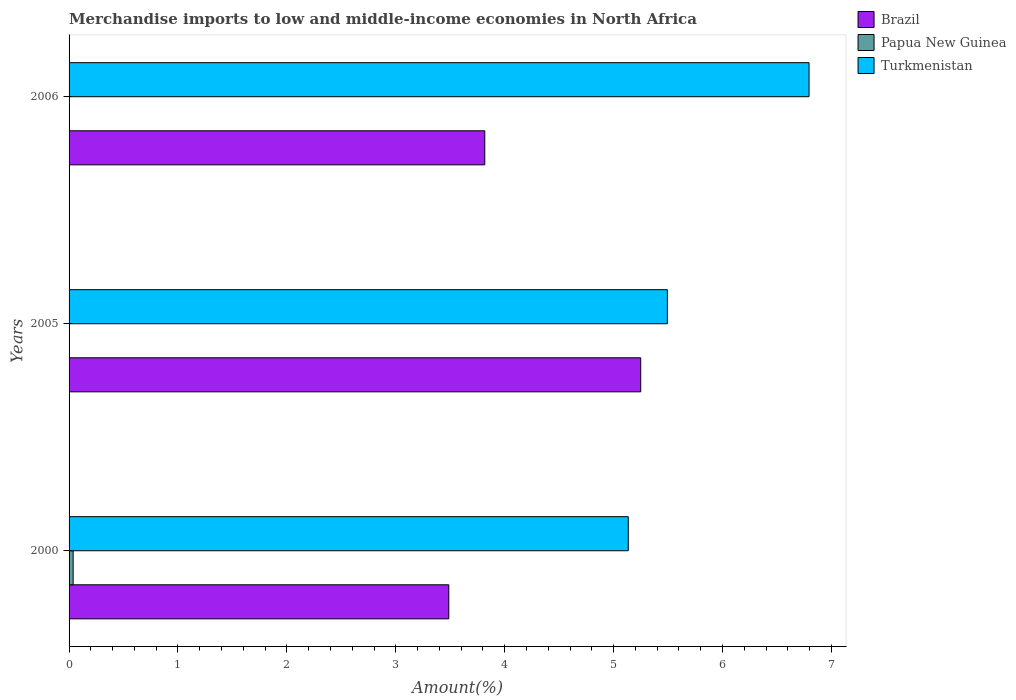How many different coloured bars are there?
Provide a succinct answer. 3. How many bars are there on the 2nd tick from the bottom?
Your answer should be very brief. 3. What is the percentage of amount earned from merchandise imports in Brazil in 2006?
Give a very brief answer. 3.82. Across all years, what is the maximum percentage of amount earned from merchandise imports in Brazil?
Provide a succinct answer. 5.25. Across all years, what is the minimum percentage of amount earned from merchandise imports in Brazil?
Keep it short and to the point. 3.49. In which year was the percentage of amount earned from merchandise imports in Brazil minimum?
Offer a very short reply. 2000. What is the total percentage of amount earned from merchandise imports in Brazil in the graph?
Keep it short and to the point. 12.55. What is the difference between the percentage of amount earned from merchandise imports in Papua New Guinea in 2000 and that in 2006?
Your response must be concise. 0.04. What is the difference between the percentage of amount earned from merchandise imports in Turkmenistan in 2006 and the percentage of amount earned from merchandise imports in Brazil in 2000?
Your answer should be compact. 3.31. What is the average percentage of amount earned from merchandise imports in Turkmenistan per year?
Your answer should be compact. 5.81. In the year 2000, what is the difference between the percentage of amount earned from merchandise imports in Brazil and percentage of amount earned from merchandise imports in Turkmenistan?
Make the answer very short. -1.65. What is the ratio of the percentage of amount earned from merchandise imports in Papua New Guinea in 2000 to that in 2005?
Give a very brief answer. 518.41. What is the difference between the highest and the second highest percentage of amount earned from merchandise imports in Turkmenistan?
Your answer should be very brief. 1.3. What is the difference between the highest and the lowest percentage of amount earned from merchandise imports in Papua New Guinea?
Make the answer very short. 0.04. What does the 3rd bar from the top in 2000 represents?
Your response must be concise. Brazil. What does the 2nd bar from the bottom in 2005 represents?
Keep it short and to the point. Papua New Guinea. Is it the case that in every year, the sum of the percentage of amount earned from merchandise imports in Papua New Guinea and percentage of amount earned from merchandise imports in Brazil is greater than the percentage of amount earned from merchandise imports in Turkmenistan?
Ensure brevity in your answer.  No. What is the difference between two consecutive major ticks on the X-axis?
Ensure brevity in your answer.  1. Does the graph contain any zero values?
Your answer should be very brief. No. Does the graph contain grids?
Your answer should be compact. No. How many legend labels are there?
Offer a terse response. 3. How are the legend labels stacked?
Offer a terse response. Vertical. What is the title of the graph?
Keep it short and to the point. Merchandise imports to low and middle-income economies in North Africa. Does "India" appear as one of the legend labels in the graph?
Your response must be concise. No. What is the label or title of the X-axis?
Offer a very short reply. Amount(%). What is the Amount(%) in Brazil in 2000?
Your answer should be very brief. 3.49. What is the Amount(%) in Papua New Guinea in 2000?
Offer a terse response. 0.04. What is the Amount(%) in Turkmenistan in 2000?
Your answer should be compact. 5.13. What is the Amount(%) of Brazil in 2005?
Provide a succinct answer. 5.25. What is the Amount(%) of Papua New Guinea in 2005?
Your answer should be compact. 7.19681476465821e-5. What is the Amount(%) in Turkmenistan in 2005?
Give a very brief answer. 5.49. What is the Amount(%) of Brazil in 2006?
Provide a short and direct response. 3.82. What is the Amount(%) in Papua New Guinea in 2006?
Offer a very short reply. 0. What is the Amount(%) of Turkmenistan in 2006?
Your answer should be compact. 6.79. Across all years, what is the maximum Amount(%) of Brazil?
Offer a very short reply. 5.25. Across all years, what is the maximum Amount(%) of Papua New Guinea?
Make the answer very short. 0.04. Across all years, what is the maximum Amount(%) of Turkmenistan?
Make the answer very short. 6.79. Across all years, what is the minimum Amount(%) in Brazil?
Make the answer very short. 3.49. Across all years, what is the minimum Amount(%) of Papua New Guinea?
Keep it short and to the point. 7.19681476465821e-5. Across all years, what is the minimum Amount(%) in Turkmenistan?
Offer a very short reply. 5.13. What is the total Amount(%) in Brazil in the graph?
Your answer should be very brief. 12.55. What is the total Amount(%) in Papua New Guinea in the graph?
Ensure brevity in your answer.  0.04. What is the total Amount(%) of Turkmenistan in the graph?
Keep it short and to the point. 17.42. What is the difference between the Amount(%) in Brazil in 2000 and that in 2005?
Offer a very short reply. -1.76. What is the difference between the Amount(%) in Papua New Guinea in 2000 and that in 2005?
Your response must be concise. 0.04. What is the difference between the Amount(%) in Turkmenistan in 2000 and that in 2005?
Offer a very short reply. -0.36. What is the difference between the Amount(%) in Brazil in 2000 and that in 2006?
Your answer should be very brief. -0.33. What is the difference between the Amount(%) of Papua New Guinea in 2000 and that in 2006?
Give a very brief answer. 0.04. What is the difference between the Amount(%) in Turkmenistan in 2000 and that in 2006?
Provide a short and direct response. -1.66. What is the difference between the Amount(%) of Brazil in 2005 and that in 2006?
Offer a terse response. 1.43. What is the difference between the Amount(%) of Papua New Guinea in 2005 and that in 2006?
Provide a succinct answer. -0. What is the difference between the Amount(%) of Turkmenistan in 2005 and that in 2006?
Make the answer very short. -1.3. What is the difference between the Amount(%) in Brazil in 2000 and the Amount(%) in Papua New Guinea in 2005?
Your answer should be very brief. 3.49. What is the difference between the Amount(%) of Brazil in 2000 and the Amount(%) of Turkmenistan in 2005?
Your answer should be compact. -2.01. What is the difference between the Amount(%) of Papua New Guinea in 2000 and the Amount(%) of Turkmenistan in 2005?
Your answer should be compact. -5.46. What is the difference between the Amount(%) of Brazil in 2000 and the Amount(%) of Papua New Guinea in 2006?
Ensure brevity in your answer.  3.49. What is the difference between the Amount(%) of Brazil in 2000 and the Amount(%) of Turkmenistan in 2006?
Your response must be concise. -3.31. What is the difference between the Amount(%) in Papua New Guinea in 2000 and the Amount(%) in Turkmenistan in 2006?
Your response must be concise. -6.76. What is the difference between the Amount(%) of Brazil in 2005 and the Amount(%) of Papua New Guinea in 2006?
Your answer should be compact. 5.25. What is the difference between the Amount(%) in Brazil in 2005 and the Amount(%) in Turkmenistan in 2006?
Your answer should be compact. -1.55. What is the difference between the Amount(%) of Papua New Guinea in 2005 and the Amount(%) of Turkmenistan in 2006?
Offer a very short reply. -6.79. What is the average Amount(%) of Brazil per year?
Your response must be concise. 4.18. What is the average Amount(%) of Papua New Guinea per year?
Your response must be concise. 0.01. What is the average Amount(%) of Turkmenistan per year?
Your answer should be very brief. 5.81. In the year 2000, what is the difference between the Amount(%) in Brazil and Amount(%) in Papua New Guinea?
Offer a terse response. 3.45. In the year 2000, what is the difference between the Amount(%) of Brazil and Amount(%) of Turkmenistan?
Offer a very short reply. -1.65. In the year 2000, what is the difference between the Amount(%) in Papua New Guinea and Amount(%) in Turkmenistan?
Offer a very short reply. -5.1. In the year 2005, what is the difference between the Amount(%) of Brazil and Amount(%) of Papua New Guinea?
Make the answer very short. 5.25. In the year 2005, what is the difference between the Amount(%) of Brazil and Amount(%) of Turkmenistan?
Your response must be concise. -0.24. In the year 2005, what is the difference between the Amount(%) of Papua New Guinea and Amount(%) of Turkmenistan?
Provide a short and direct response. -5.49. In the year 2006, what is the difference between the Amount(%) of Brazil and Amount(%) of Papua New Guinea?
Your answer should be very brief. 3.82. In the year 2006, what is the difference between the Amount(%) in Brazil and Amount(%) in Turkmenistan?
Ensure brevity in your answer.  -2.98. In the year 2006, what is the difference between the Amount(%) of Papua New Guinea and Amount(%) of Turkmenistan?
Give a very brief answer. -6.79. What is the ratio of the Amount(%) of Brazil in 2000 to that in 2005?
Make the answer very short. 0.66. What is the ratio of the Amount(%) of Papua New Guinea in 2000 to that in 2005?
Provide a short and direct response. 518.41. What is the ratio of the Amount(%) of Turkmenistan in 2000 to that in 2005?
Keep it short and to the point. 0.93. What is the ratio of the Amount(%) in Brazil in 2000 to that in 2006?
Offer a very short reply. 0.91. What is the ratio of the Amount(%) in Papua New Guinea in 2000 to that in 2006?
Make the answer very short. 29.94. What is the ratio of the Amount(%) of Turkmenistan in 2000 to that in 2006?
Ensure brevity in your answer.  0.76. What is the ratio of the Amount(%) of Brazil in 2005 to that in 2006?
Give a very brief answer. 1.38. What is the ratio of the Amount(%) of Papua New Guinea in 2005 to that in 2006?
Offer a terse response. 0.06. What is the ratio of the Amount(%) in Turkmenistan in 2005 to that in 2006?
Keep it short and to the point. 0.81. What is the difference between the highest and the second highest Amount(%) in Brazil?
Your answer should be compact. 1.43. What is the difference between the highest and the second highest Amount(%) of Papua New Guinea?
Your answer should be compact. 0.04. What is the difference between the highest and the second highest Amount(%) of Turkmenistan?
Provide a short and direct response. 1.3. What is the difference between the highest and the lowest Amount(%) in Brazil?
Keep it short and to the point. 1.76. What is the difference between the highest and the lowest Amount(%) of Papua New Guinea?
Make the answer very short. 0.04. What is the difference between the highest and the lowest Amount(%) in Turkmenistan?
Make the answer very short. 1.66. 